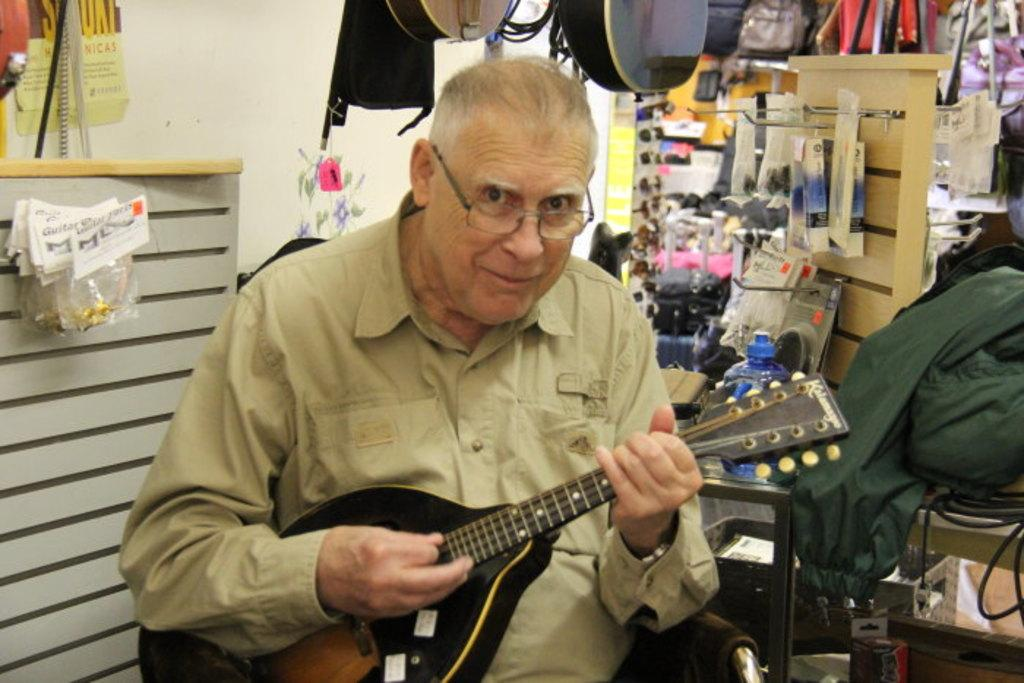What is the man in the image holding? The man is holding a music instrument. Can you describe the setting where the man is located? There is a table and a wall in the image, suggesting that the man might be in a room or an indoor setting. What type of exchange is taking place between the man and the wall in the image? There is no exchange taking place between the man and the wall in the image. What type of stitch is the man using to play the music instrument in the image? The man is not using any stitch to play the music instrument in the image; he is likely using his hands or fingers. 